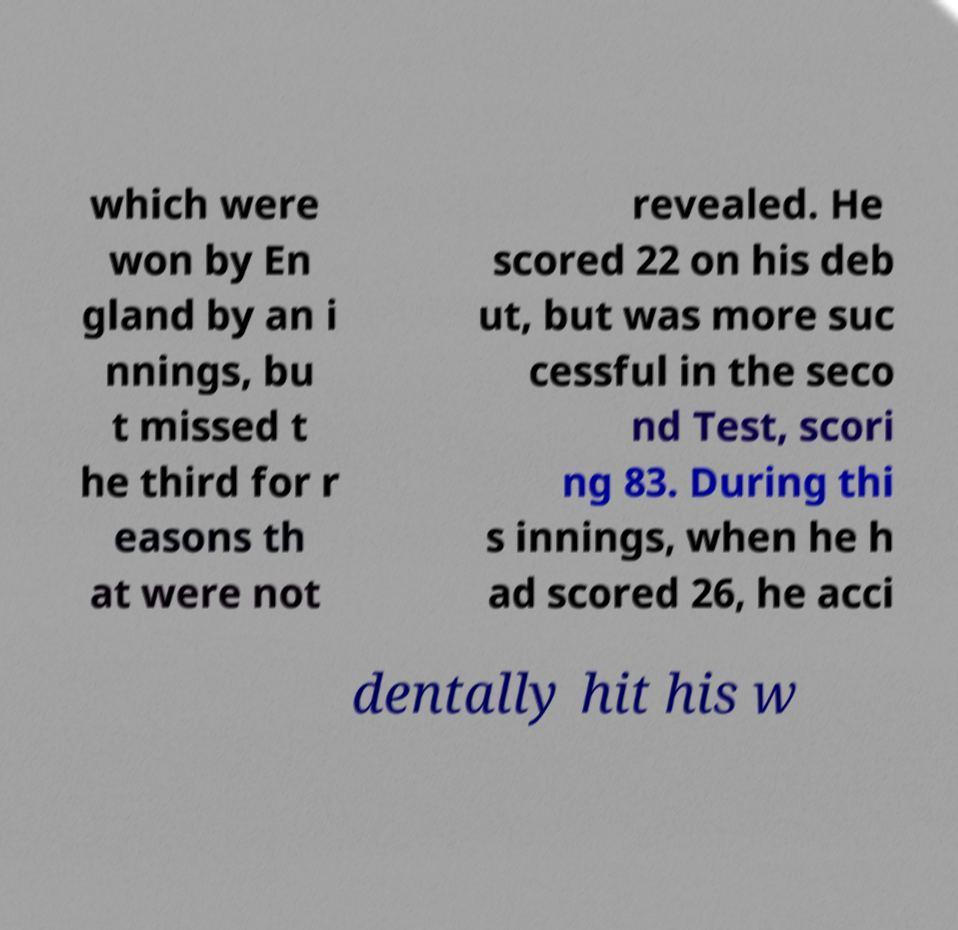What messages or text are displayed in this image? I need them in a readable, typed format. which were won by En gland by an i nnings, bu t missed t he third for r easons th at were not revealed. He scored 22 on his deb ut, but was more suc cessful in the seco nd Test, scori ng 83. During thi s innings, when he h ad scored 26, he acci dentally hit his w 